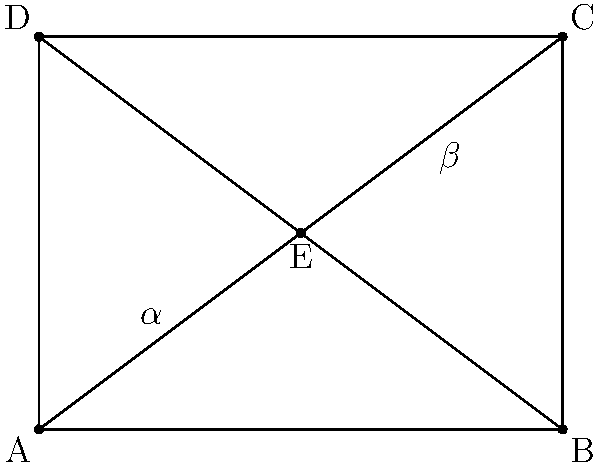In a rectangular chessboard ABCD, the diagonals AC and BD intersect at point E. If the angle AEB is denoted as $\alpha$ and the angle CED is denoted as $\beta$, prove that $\alpha + \beta = 180°$. Let's approach this step-by-step:

1) In a rectangle, opposite sides are parallel and equal in length. Therefore, ABCD is a rectangle.

2) The diagonals of a rectangle bisect each other. This means that point E is the midpoint of both AC and BD.

3) In triangle AEB:
   - AE is half of AC
   - BE is half of BD
   - AB is a side of the rectangle

4) Similarly, in triangle CED:
   - CE is half of AC
   - DE is half of BD
   - CD is a side of the rectangle

5) Therefore, triangles AEB and CED are similar to the whole rectangle, but at half the scale.

6) In a rectangle, adjacent angles are supplementary (they add up to 180°).

7) Since triangles AEB and CED are similar to the whole rectangle, their corresponding angles at E (α and β) must also be supplementary.

Therefore, $\alpha + \beta = 180°$.
Answer: $\alpha + \beta = 180°$ 